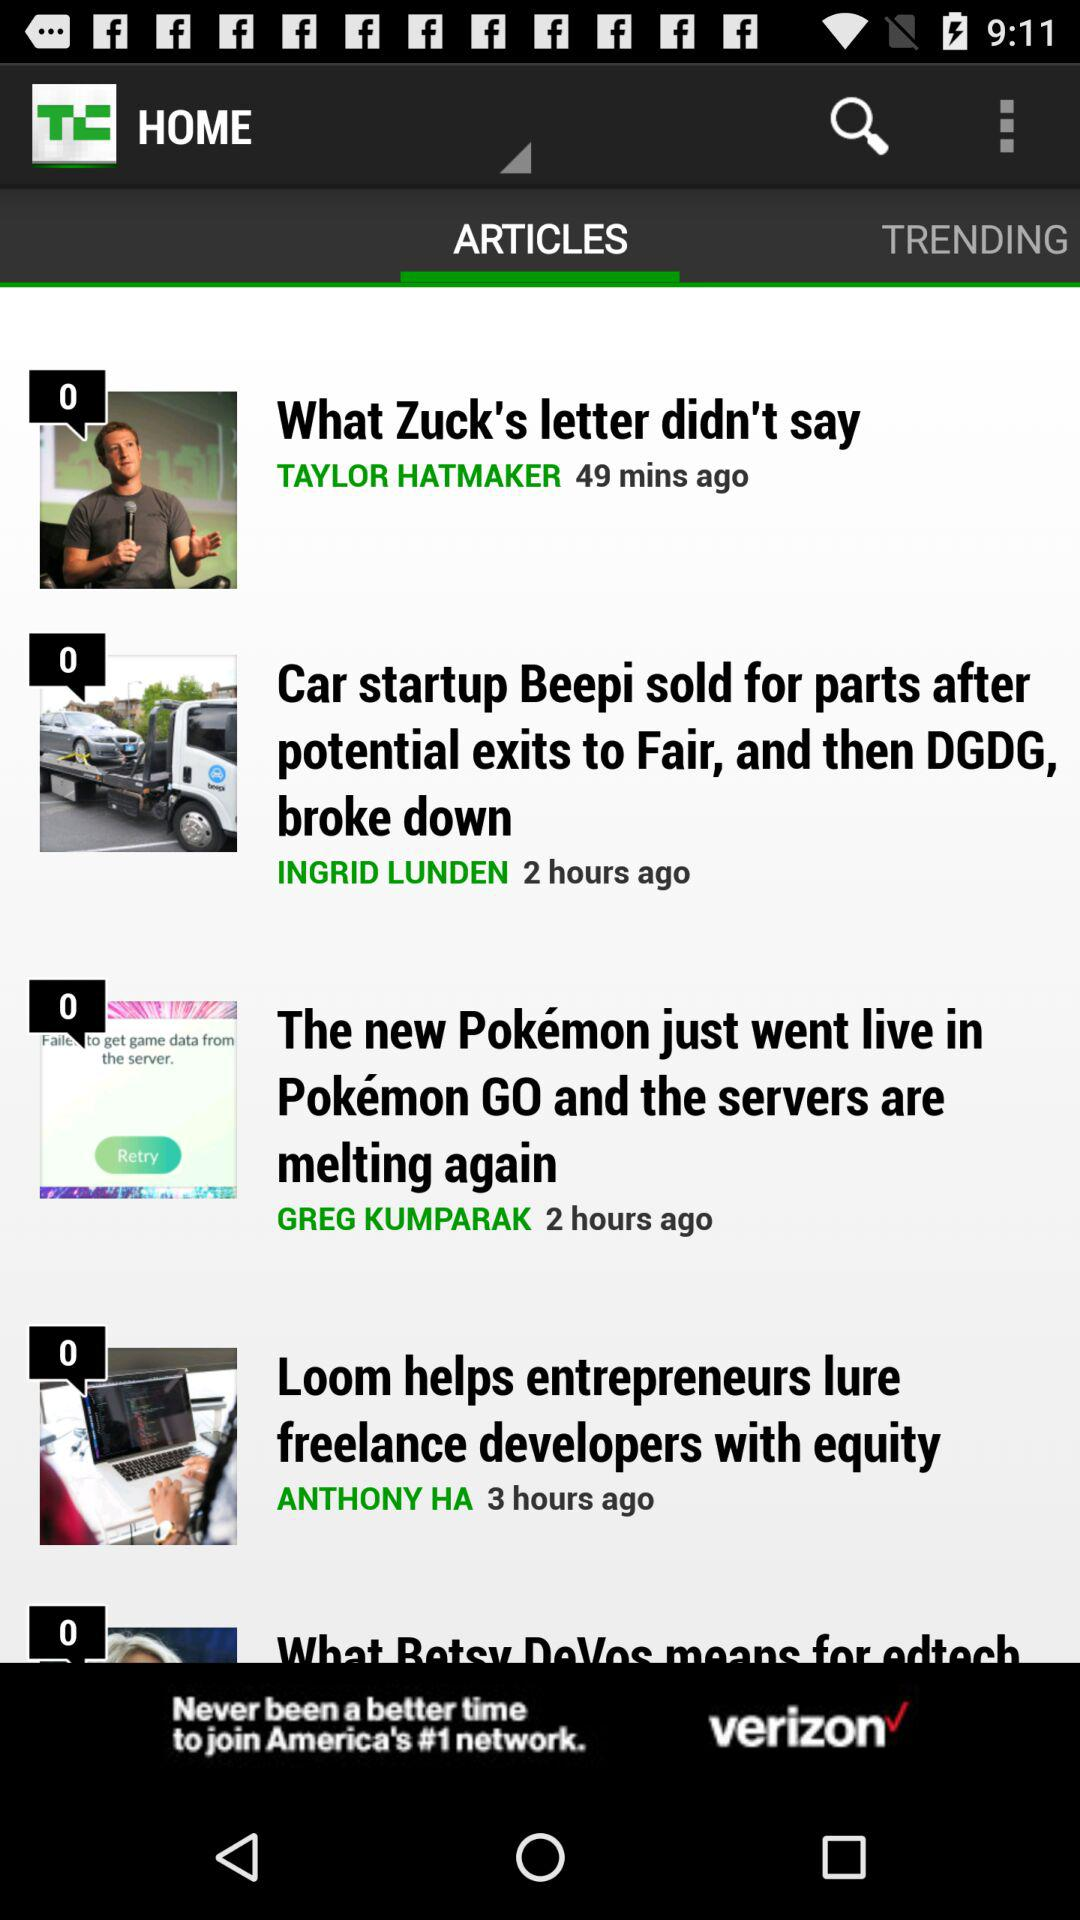How many comments are given for the article "What Zuck's letter didn't say"? There are 0 comments given for the article "What Zuck's letter didn't say". 